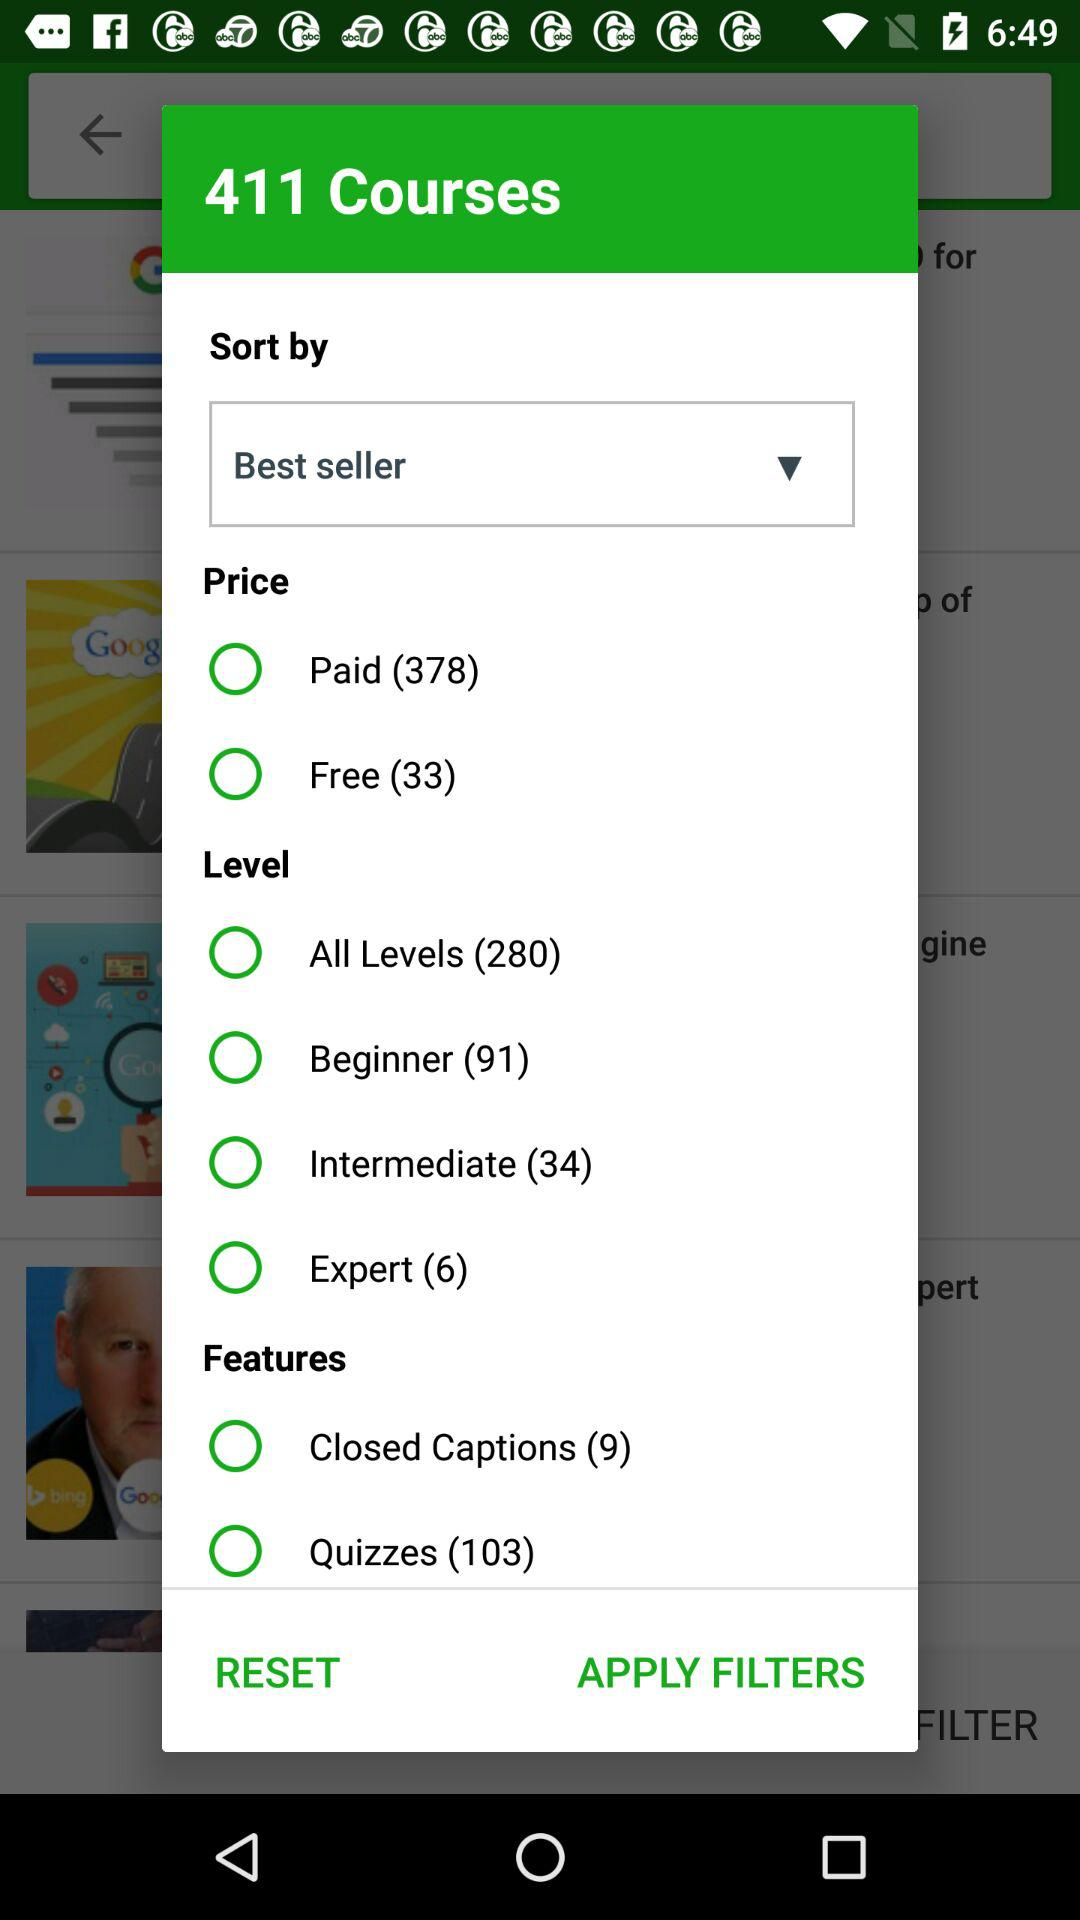What are the categories of Best Seller Features courses? The categories are "Closed Captions" and "Quizzes". 